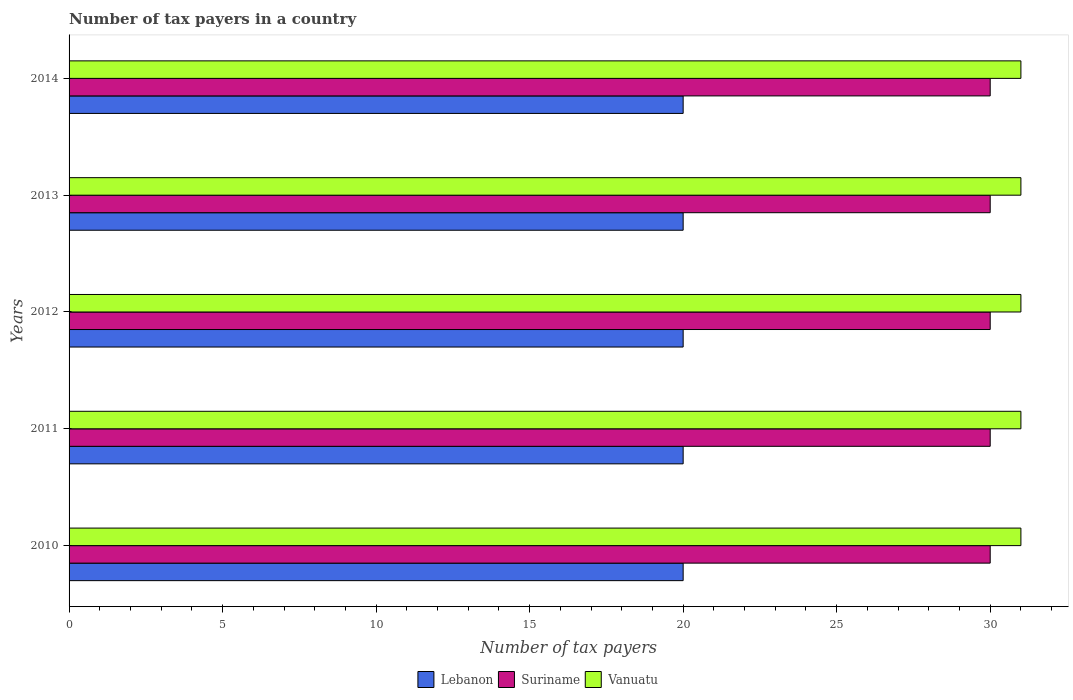How many different coloured bars are there?
Provide a succinct answer. 3. How many groups of bars are there?
Offer a very short reply. 5. Are the number of bars per tick equal to the number of legend labels?
Your answer should be very brief. Yes. What is the number of tax payers in in Suriname in 2013?
Make the answer very short. 30. Across all years, what is the maximum number of tax payers in in Suriname?
Offer a very short reply. 30. Across all years, what is the minimum number of tax payers in in Vanuatu?
Your answer should be very brief. 31. In which year was the number of tax payers in in Suriname maximum?
Your response must be concise. 2010. In which year was the number of tax payers in in Suriname minimum?
Keep it short and to the point. 2010. What is the total number of tax payers in in Vanuatu in the graph?
Your response must be concise. 155. What is the difference between the number of tax payers in in Suriname in 2011 and that in 2013?
Your response must be concise. 0. What is the difference between the number of tax payers in in Suriname in 2010 and the number of tax payers in in Vanuatu in 2012?
Your answer should be very brief. -1. In the year 2012, what is the difference between the number of tax payers in in Lebanon and number of tax payers in in Vanuatu?
Offer a terse response. -11. In how many years, is the number of tax payers in in Lebanon greater than 24 ?
Keep it short and to the point. 0. Is the number of tax payers in in Vanuatu in 2013 less than that in 2014?
Offer a very short reply. No. Is the sum of the number of tax payers in in Suriname in 2012 and 2014 greater than the maximum number of tax payers in in Vanuatu across all years?
Offer a very short reply. Yes. What does the 1st bar from the top in 2014 represents?
Keep it short and to the point. Vanuatu. What does the 3rd bar from the bottom in 2013 represents?
Your answer should be compact. Vanuatu. Is it the case that in every year, the sum of the number of tax payers in in Suriname and number of tax payers in in Lebanon is greater than the number of tax payers in in Vanuatu?
Give a very brief answer. Yes. Are all the bars in the graph horizontal?
Ensure brevity in your answer.  Yes. What is the difference between two consecutive major ticks on the X-axis?
Your answer should be very brief. 5. How are the legend labels stacked?
Provide a short and direct response. Horizontal. What is the title of the graph?
Your response must be concise. Number of tax payers in a country. What is the label or title of the X-axis?
Make the answer very short. Number of tax payers. What is the Number of tax payers of Suriname in 2010?
Provide a short and direct response. 30. What is the Number of tax payers in Lebanon in 2011?
Make the answer very short. 20. What is the Number of tax payers of Suriname in 2011?
Provide a short and direct response. 30. What is the Number of tax payers in Vanuatu in 2011?
Make the answer very short. 31. What is the Number of tax payers in Suriname in 2012?
Offer a very short reply. 30. What is the Number of tax payers in Vanuatu in 2012?
Offer a terse response. 31. What is the Number of tax payers of Lebanon in 2013?
Keep it short and to the point. 20. What is the Number of tax payers in Lebanon in 2014?
Ensure brevity in your answer.  20. Across all years, what is the maximum Number of tax payers in Suriname?
Your response must be concise. 30. Across all years, what is the maximum Number of tax payers in Vanuatu?
Your answer should be compact. 31. Across all years, what is the minimum Number of tax payers of Suriname?
Make the answer very short. 30. Across all years, what is the minimum Number of tax payers of Vanuatu?
Your answer should be very brief. 31. What is the total Number of tax payers in Suriname in the graph?
Offer a terse response. 150. What is the total Number of tax payers in Vanuatu in the graph?
Your answer should be very brief. 155. What is the difference between the Number of tax payers of Lebanon in 2010 and that in 2012?
Ensure brevity in your answer.  0. What is the difference between the Number of tax payers of Lebanon in 2010 and that in 2013?
Give a very brief answer. 0. What is the difference between the Number of tax payers of Vanuatu in 2010 and that in 2013?
Your answer should be very brief. 0. What is the difference between the Number of tax payers of Suriname in 2010 and that in 2014?
Give a very brief answer. 0. What is the difference between the Number of tax payers in Vanuatu in 2010 and that in 2014?
Offer a terse response. 0. What is the difference between the Number of tax payers in Lebanon in 2011 and that in 2012?
Ensure brevity in your answer.  0. What is the difference between the Number of tax payers in Suriname in 2011 and that in 2012?
Keep it short and to the point. 0. What is the difference between the Number of tax payers in Lebanon in 2011 and that in 2013?
Ensure brevity in your answer.  0. What is the difference between the Number of tax payers of Suriname in 2011 and that in 2013?
Keep it short and to the point. 0. What is the difference between the Number of tax payers of Vanuatu in 2011 and that in 2013?
Ensure brevity in your answer.  0. What is the difference between the Number of tax payers of Suriname in 2011 and that in 2014?
Your answer should be compact. 0. What is the difference between the Number of tax payers in Lebanon in 2012 and that in 2013?
Make the answer very short. 0. What is the difference between the Number of tax payers of Lebanon in 2010 and the Number of tax payers of Suriname in 2011?
Make the answer very short. -10. What is the difference between the Number of tax payers in Suriname in 2010 and the Number of tax payers in Vanuatu in 2011?
Your response must be concise. -1. What is the difference between the Number of tax payers in Suriname in 2010 and the Number of tax payers in Vanuatu in 2012?
Offer a very short reply. -1. What is the difference between the Number of tax payers of Lebanon in 2010 and the Number of tax payers of Suriname in 2013?
Offer a very short reply. -10. What is the difference between the Number of tax payers in Lebanon in 2010 and the Number of tax payers in Vanuatu in 2013?
Give a very brief answer. -11. What is the difference between the Number of tax payers in Suriname in 2010 and the Number of tax payers in Vanuatu in 2013?
Make the answer very short. -1. What is the difference between the Number of tax payers in Lebanon in 2010 and the Number of tax payers in Vanuatu in 2014?
Provide a succinct answer. -11. What is the difference between the Number of tax payers of Lebanon in 2011 and the Number of tax payers of Vanuatu in 2012?
Make the answer very short. -11. What is the difference between the Number of tax payers of Lebanon in 2012 and the Number of tax payers of Vanuatu in 2013?
Give a very brief answer. -11. What is the difference between the Number of tax payers in Lebanon in 2013 and the Number of tax payers in Vanuatu in 2014?
Offer a terse response. -11. What is the average Number of tax payers in Vanuatu per year?
Keep it short and to the point. 31. In the year 2010, what is the difference between the Number of tax payers of Lebanon and Number of tax payers of Suriname?
Your response must be concise. -10. In the year 2010, what is the difference between the Number of tax payers of Lebanon and Number of tax payers of Vanuatu?
Make the answer very short. -11. In the year 2010, what is the difference between the Number of tax payers in Suriname and Number of tax payers in Vanuatu?
Ensure brevity in your answer.  -1. In the year 2011, what is the difference between the Number of tax payers of Lebanon and Number of tax payers of Suriname?
Offer a very short reply. -10. In the year 2011, what is the difference between the Number of tax payers in Lebanon and Number of tax payers in Vanuatu?
Provide a short and direct response. -11. In the year 2011, what is the difference between the Number of tax payers of Suriname and Number of tax payers of Vanuatu?
Offer a very short reply. -1. In the year 2012, what is the difference between the Number of tax payers in Lebanon and Number of tax payers in Vanuatu?
Give a very brief answer. -11. In the year 2013, what is the difference between the Number of tax payers of Lebanon and Number of tax payers of Vanuatu?
Your answer should be compact. -11. In the year 2014, what is the difference between the Number of tax payers in Lebanon and Number of tax payers in Suriname?
Give a very brief answer. -10. What is the ratio of the Number of tax payers of Vanuatu in 2010 to that in 2011?
Provide a succinct answer. 1. What is the ratio of the Number of tax payers of Suriname in 2010 to that in 2012?
Ensure brevity in your answer.  1. What is the ratio of the Number of tax payers of Vanuatu in 2010 to that in 2012?
Give a very brief answer. 1. What is the ratio of the Number of tax payers of Lebanon in 2010 to that in 2013?
Provide a succinct answer. 1. What is the ratio of the Number of tax payers of Suriname in 2010 to that in 2013?
Provide a succinct answer. 1. What is the ratio of the Number of tax payers in Lebanon in 2010 to that in 2014?
Provide a short and direct response. 1. What is the ratio of the Number of tax payers in Vanuatu in 2010 to that in 2014?
Provide a short and direct response. 1. What is the ratio of the Number of tax payers in Lebanon in 2011 to that in 2012?
Offer a terse response. 1. What is the ratio of the Number of tax payers of Vanuatu in 2011 to that in 2012?
Provide a short and direct response. 1. What is the ratio of the Number of tax payers in Vanuatu in 2011 to that in 2013?
Ensure brevity in your answer.  1. What is the ratio of the Number of tax payers of Suriname in 2011 to that in 2014?
Offer a very short reply. 1. What is the ratio of the Number of tax payers of Suriname in 2012 to that in 2013?
Make the answer very short. 1. What is the ratio of the Number of tax payers of Vanuatu in 2012 to that in 2013?
Your answer should be very brief. 1. What is the ratio of the Number of tax payers in Lebanon in 2013 to that in 2014?
Ensure brevity in your answer.  1. What is the ratio of the Number of tax payers in Suriname in 2013 to that in 2014?
Keep it short and to the point. 1. What is the difference between the highest and the lowest Number of tax payers in Suriname?
Provide a short and direct response. 0. 